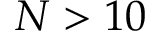<formula> <loc_0><loc_0><loc_500><loc_500>N > 1 0</formula> 